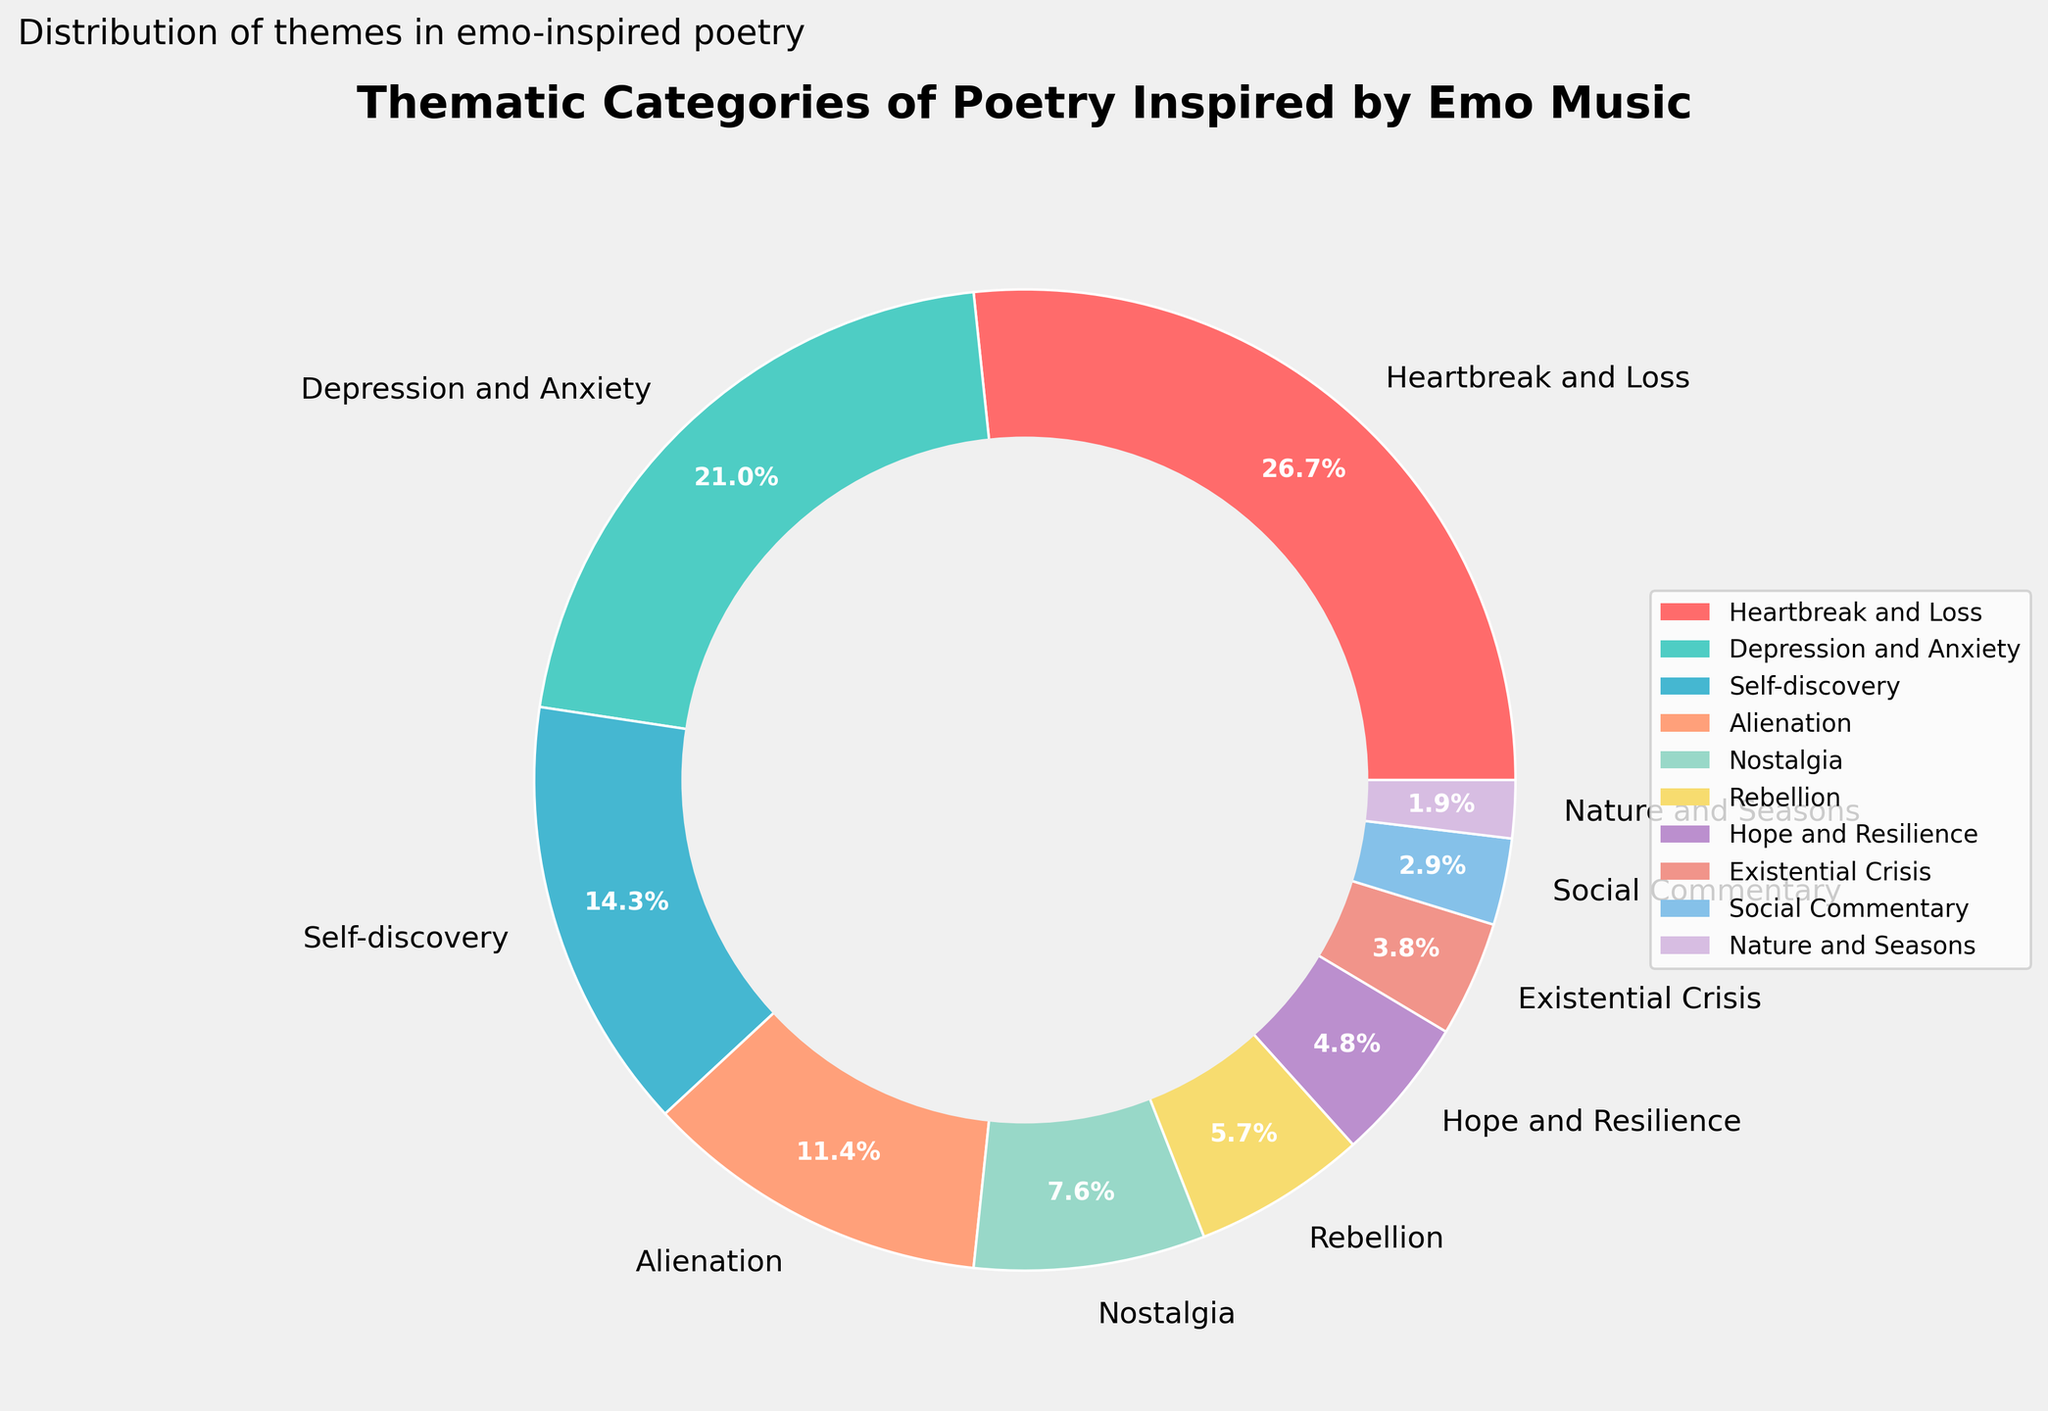what percentage of the poetry themes are represented by themes other than "Heartbreak and Loss" and "Depression and Anxiety"? First, identify the percentages for "Heartbreak and Loss" (28%) and "Depression and Anxiety" (22%). Together, these two themes make up 28 + 22 = 50% of the chart. To find the percentage represented by all other themes, subtract this sum from 100%: 100 - 50 = 50%.
Answer: 50% Which theme has a slightly higher percentage, "Self-discovery" or "Alienation"? Compare the percentages for both themes: "Self-discovery" is at 15%, while "Alienation" is at 12%. "Self-discovery" has a slightly higher percentage than "Alienation".
Answer: Self-discovery What is the combined percentage of themes related to positive emotions, specifically "Hope and Resilience" and "Self-discovery"? Sum the percentages of "Hope and Resilience" (5%) and "Self-discovery" (15%): 5 + 15 = 20%. The combined percentage is 20%.
Answer: 20% Which theme is represented by the pink-colored section of the pie chart? The theme represented by the pink-colored section is "Heartbreak and Loss". This can be inferred from the custom color palette and the visual appearance of the chart.
Answer: Heartbreak and Loss Are there more themes with percentages above or below 10%? Identify the themes above 10%: "Heartbreak and Loss" (28%), "Depression and Anxiety" (22%), "Self-discovery" (15%), "Alienation" (12%). Themes below 10%: "Nostalgia" (8%), "Rebellion" (6%), "Hope and Resilience" (5%), "Existential Crisis" (4%), "Social Commentary" (3%), "Nature and Seasons" (2%). There are 4 themes above 10% and 6 themes below 10%.
Answer: Below 10% What is the difference in percentage between the themes "Nostalgia" and "Existential Crisis"? Subtract the percentage of "Existential Crisis" (4%) from the percentage of "Nostalgia" (8%): 8 - 4 = 4%. The difference is 4%.
Answer: 4% Which theme's proportion in the pie chart is equivalent to the sum of the proportions of "Rebellion" and "Existential Crisis"? First, find the sum of the proportions of "Rebellion" (6%) and "Existential Crisis" (4%): 6 + 4 = 10%. The theme with the equivalent proportion is "Nostalgia" which is also 8%.
Answer: Nostalgia 